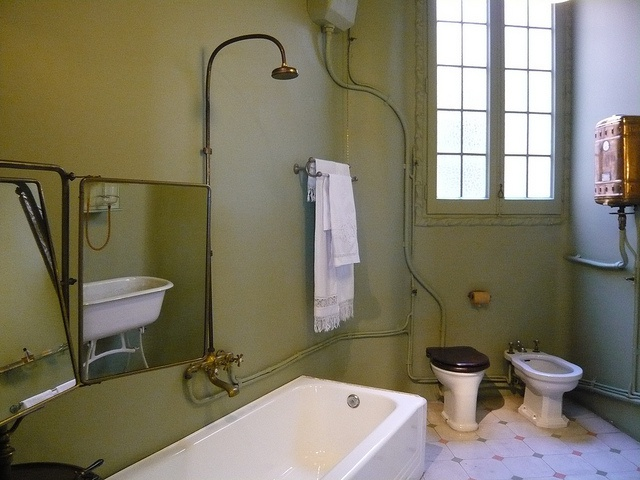Describe the objects in this image and their specific colors. I can see sink in olive, gray, and black tones, toilet in olive and gray tones, and toilet in olive, black, tan, darkgray, and gray tones in this image. 